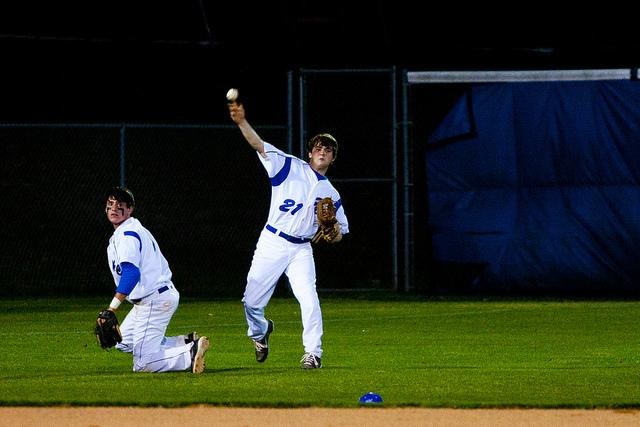What position is played by the kneeling player?

Choices:
A) catcher
B) outfield
C) pitcher
D) short stop outfield 